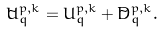Convert formula to latex. <formula><loc_0><loc_0><loc_500><loc_500>\tilde { U } _ { q } ^ { { p } , { k } } = U _ { q } ^ { { p } , { k } } + \tilde { D } _ { q } ^ { { p } , { k } } .</formula> 